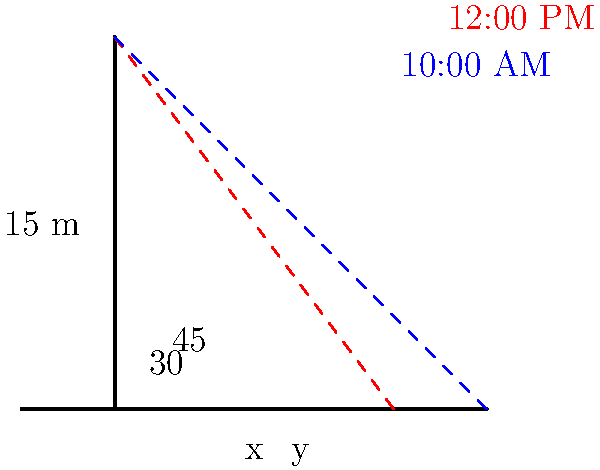A 15-meter flagpole casts shadows of different lengths throughout the day. At 10:00 AM, the angle of elevation of the sun is 30°, and at 12:00 PM, it increases to 45°. Calculate the difference in shadow lengths between these two times. Let's approach this step-by-step:

1) First, we need to calculate the shadow length at 10:00 AM:
   Using the tangent ratio: $\tan 30° = \frac{15}{x}$
   $x = \frac{15}{\tan 30°} = \frac{15}{\frac{1}{\sqrt{3}}} = 15\sqrt{3} \approx 25.98$ meters

2) Now, let's calculate the shadow length at 12:00 PM:
   Using the tangent ratio again: $\tan 45° = \frac{15}{y}$
   $y = \frac{15}{\tan 45°} = \frac{15}{1} = 15$ meters

3) To find the difference in shadow lengths, we subtract:
   Difference = Shadow length at 10:00 AM - Shadow length at 12:00 PM
               = $15\sqrt{3} - 15$
               = $15(\sqrt{3} - 1)$
               $\approx 10.98$ meters

Therefore, the difference in shadow lengths between 10:00 AM and 12:00 PM is $15(\sqrt{3} - 1)$ meters.
Answer: $15(\sqrt{3} - 1)$ meters 